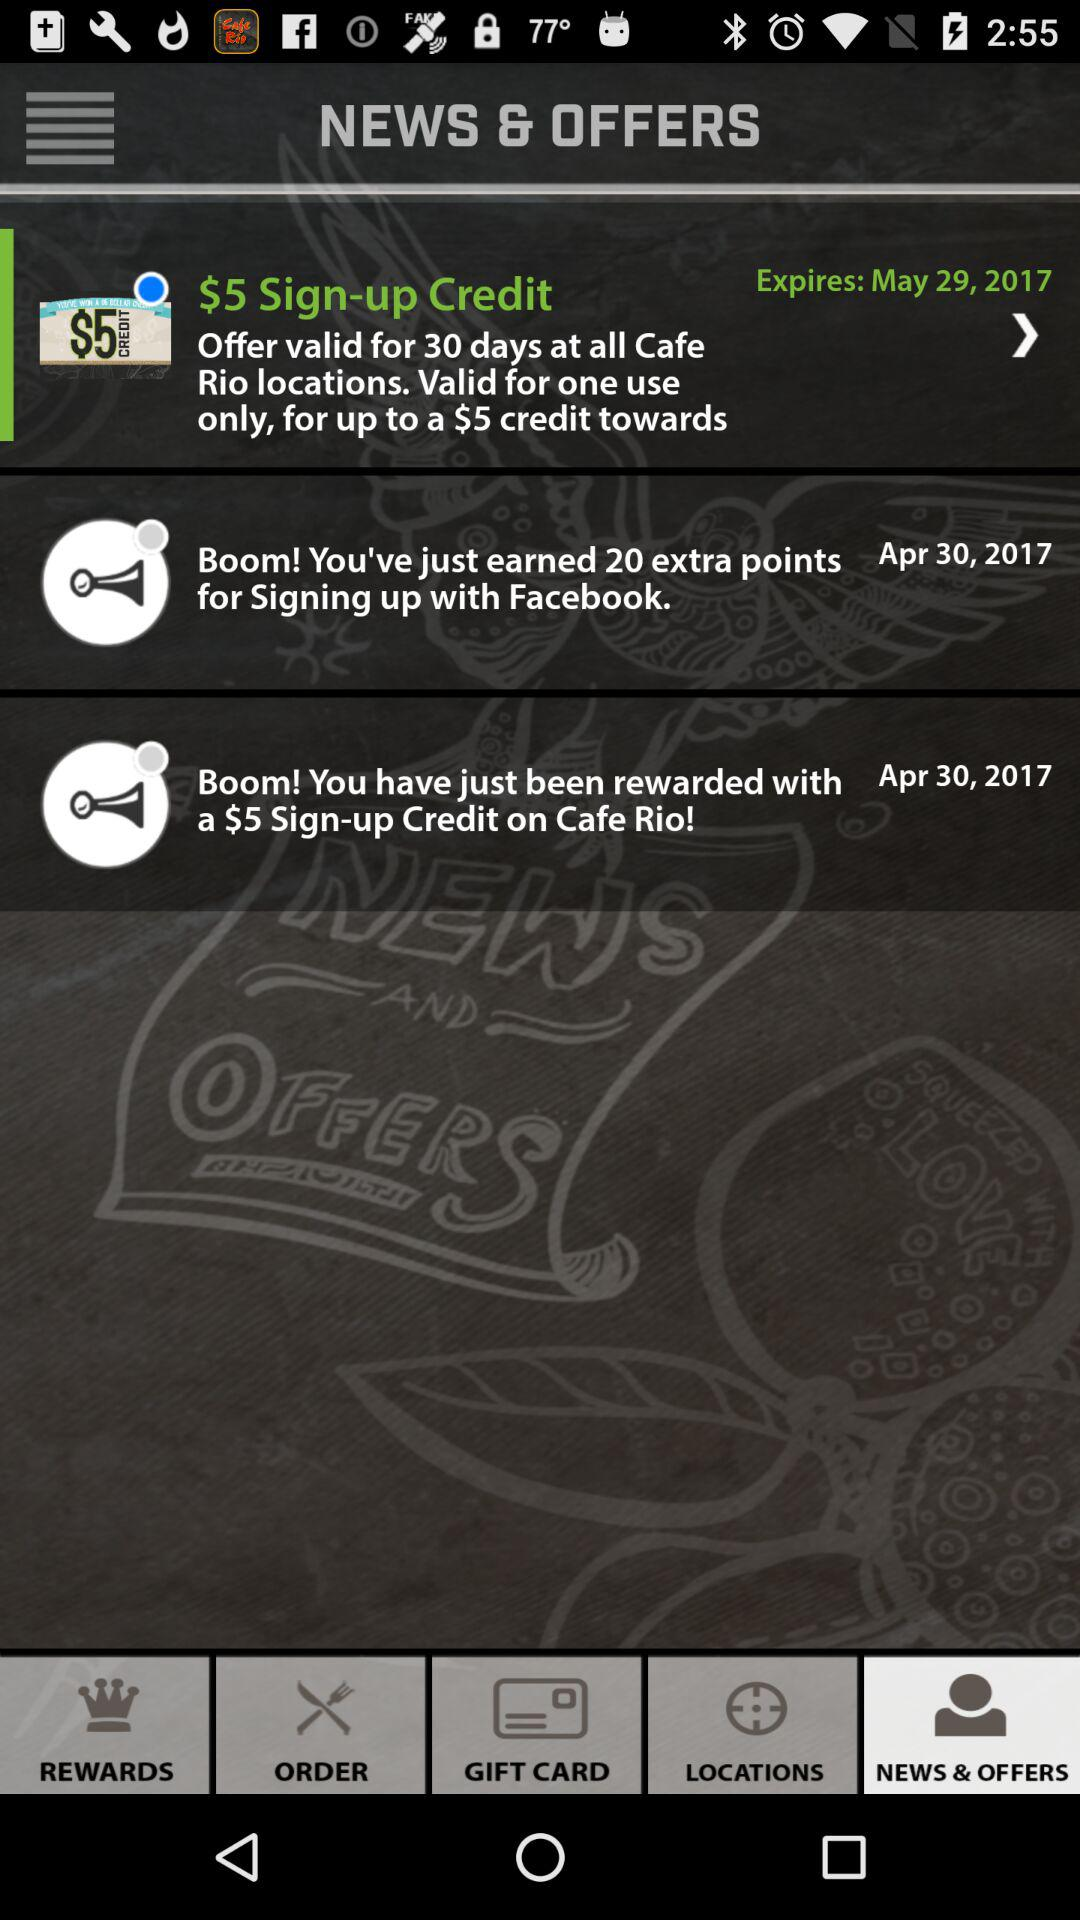What is the expiry date for the "$5 Sign-up credit"? The expiry date is May 29, 2017. 